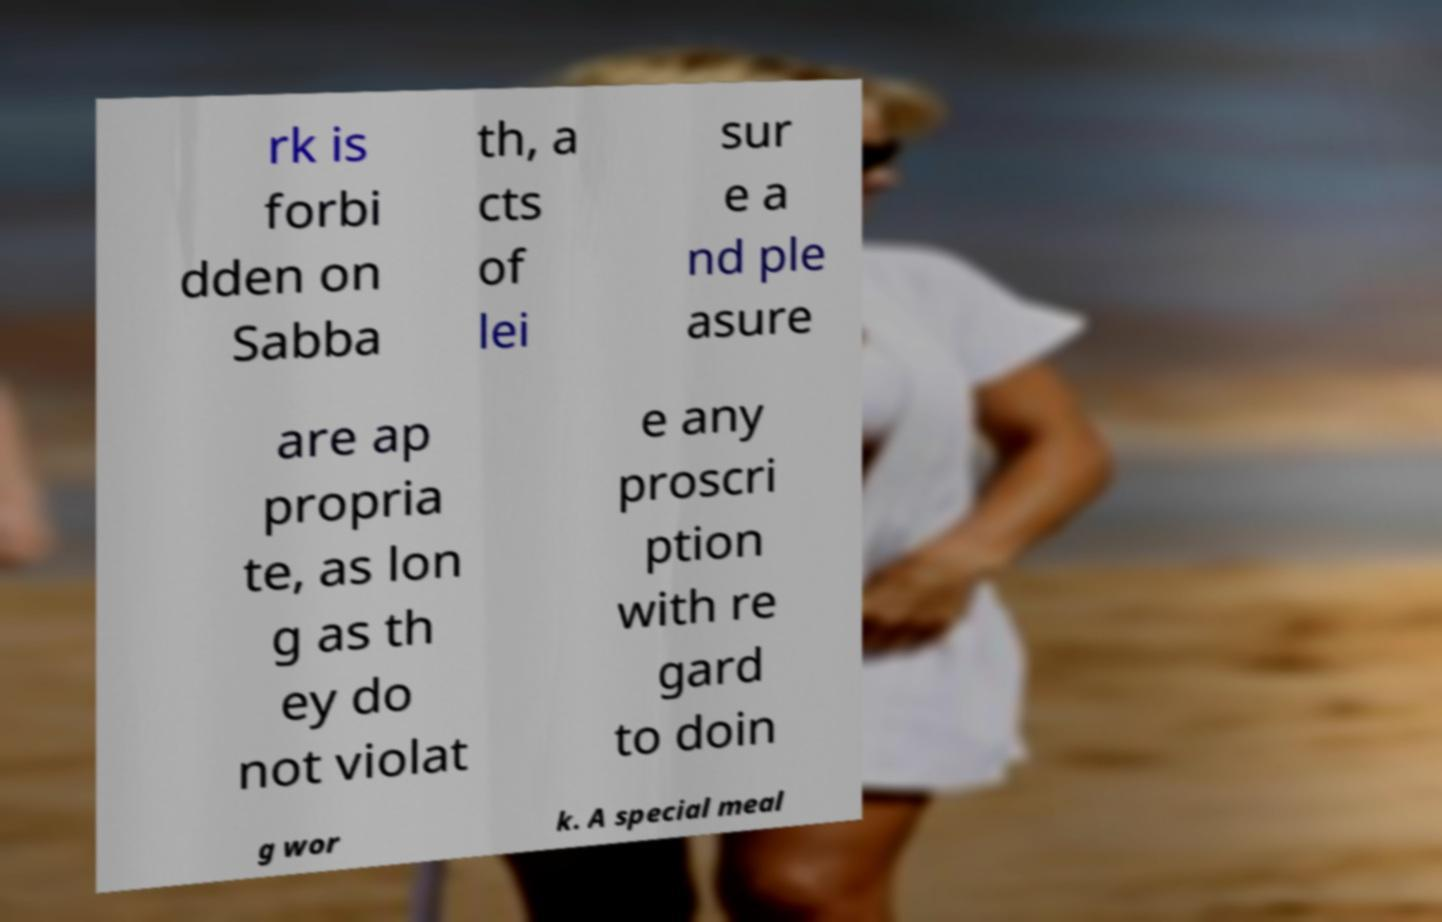For documentation purposes, I need the text within this image transcribed. Could you provide that? rk is forbi dden on Sabba th, a cts of lei sur e a nd ple asure are ap propria te, as lon g as th ey do not violat e any proscri ption with re gard to doin g wor k. A special meal 